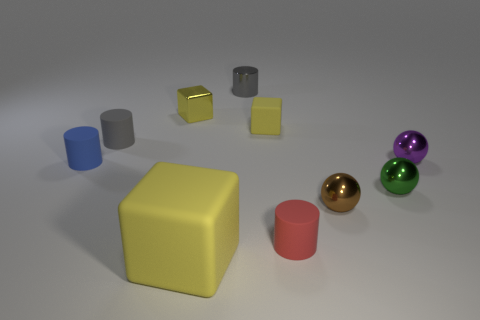Imagine this is a scene from a story. What narrative could these items be a part of? One could imagine this scene as a moment frozen in time within a child's playroom, where each object represents a character or element in a fantastical journey. Perhaps the sphere is a magical pearl sought by the cubic heroes, and the cylinders are pillars to an invisible castle. The narrative could revolve around a quest to bring harmony to a geometric kingdom, with each shape's characteristics influencing its role in the story. 